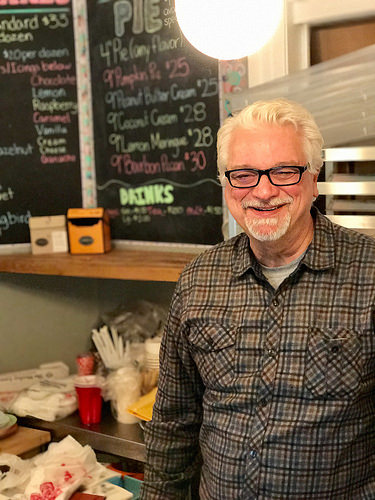<image>
Is there a box in front of the board? Yes. The box is positioned in front of the board, appearing closer to the camera viewpoint. 